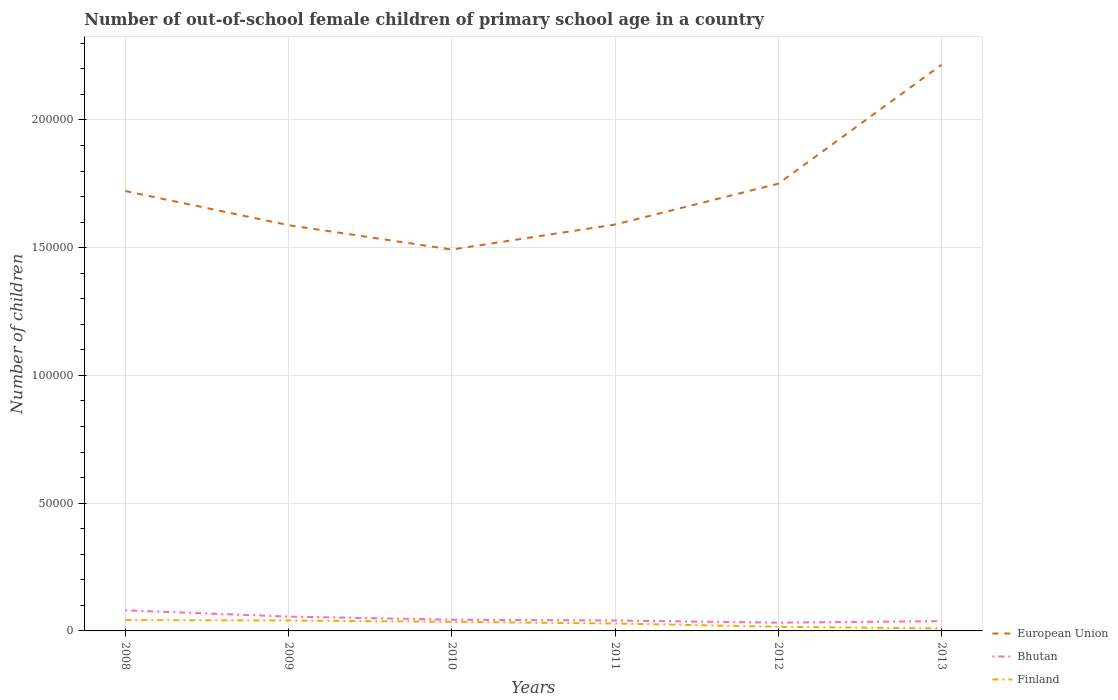How many different coloured lines are there?
Ensure brevity in your answer.  3. Is the number of lines equal to the number of legend labels?
Keep it short and to the point. Yes. Across all years, what is the maximum number of out-of-school female children in Bhutan?
Make the answer very short. 3236. What is the total number of out-of-school female children in Finland in the graph?
Give a very brief answer. 177. What is the difference between the highest and the second highest number of out-of-school female children in European Union?
Offer a very short reply. 7.23e+04. What is the difference between the highest and the lowest number of out-of-school female children in Finland?
Provide a succinct answer. 3. How many lines are there?
Give a very brief answer. 3. Are the values on the major ticks of Y-axis written in scientific E-notation?
Offer a terse response. No. Does the graph contain any zero values?
Keep it short and to the point. No. Where does the legend appear in the graph?
Your answer should be very brief. Bottom right. How are the legend labels stacked?
Keep it short and to the point. Vertical. What is the title of the graph?
Your answer should be compact. Number of out-of-school female children of primary school age in a country. Does "Turkey" appear as one of the legend labels in the graph?
Your answer should be very brief. No. What is the label or title of the Y-axis?
Ensure brevity in your answer.  Number of children. What is the Number of children in European Union in 2008?
Provide a short and direct response. 1.72e+05. What is the Number of children in Bhutan in 2008?
Your answer should be very brief. 8066. What is the Number of children of Finland in 2008?
Your response must be concise. 4262. What is the Number of children in European Union in 2009?
Provide a short and direct response. 1.59e+05. What is the Number of children of Bhutan in 2009?
Your response must be concise. 5613. What is the Number of children in Finland in 2009?
Offer a terse response. 4085. What is the Number of children in European Union in 2010?
Provide a succinct answer. 1.49e+05. What is the Number of children of Bhutan in 2010?
Ensure brevity in your answer.  4390. What is the Number of children in Finland in 2010?
Give a very brief answer. 3564. What is the Number of children in European Union in 2011?
Provide a short and direct response. 1.59e+05. What is the Number of children in Bhutan in 2011?
Give a very brief answer. 4072. What is the Number of children in Finland in 2011?
Make the answer very short. 2896. What is the Number of children in European Union in 2012?
Your answer should be compact. 1.75e+05. What is the Number of children in Bhutan in 2012?
Provide a short and direct response. 3236. What is the Number of children of Finland in 2012?
Give a very brief answer. 1629. What is the Number of children in European Union in 2013?
Provide a short and direct response. 2.22e+05. What is the Number of children of Bhutan in 2013?
Provide a succinct answer. 3839. What is the Number of children of Finland in 2013?
Your answer should be very brief. 958. Across all years, what is the maximum Number of children in European Union?
Your answer should be compact. 2.22e+05. Across all years, what is the maximum Number of children of Bhutan?
Ensure brevity in your answer.  8066. Across all years, what is the maximum Number of children of Finland?
Your response must be concise. 4262. Across all years, what is the minimum Number of children in European Union?
Make the answer very short. 1.49e+05. Across all years, what is the minimum Number of children in Bhutan?
Make the answer very short. 3236. Across all years, what is the minimum Number of children in Finland?
Offer a terse response. 958. What is the total Number of children in European Union in the graph?
Your answer should be very brief. 1.04e+06. What is the total Number of children of Bhutan in the graph?
Give a very brief answer. 2.92e+04. What is the total Number of children in Finland in the graph?
Provide a short and direct response. 1.74e+04. What is the difference between the Number of children in European Union in 2008 and that in 2009?
Your answer should be compact. 1.34e+04. What is the difference between the Number of children in Bhutan in 2008 and that in 2009?
Keep it short and to the point. 2453. What is the difference between the Number of children of Finland in 2008 and that in 2009?
Provide a succinct answer. 177. What is the difference between the Number of children in European Union in 2008 and that in 2010?
Your response must be concise. 2.29e+04. What is the difference between the Number of children in Bhutan in 2008 and that in 2010?
Provide a succinct answer. 3676. What is the difference between the Number of children in Finland in 2008 and that in 2010?
Give a very brief answer. 698. What is the difference between the Number of children in European Union in 2008 and that in 2011?
Make the answer very short. 1.31e+04. What is the difference between the Number of children of Bhutan in 2008 and that in 2011?
Your answer should be compact. 3994. What is the difference between the Number of children in Finland in 2008 and that in 2011?
Provide a short and direct response. 1366. What is the difference between the Number of children in European Union in 2008 and that in 2012?
Provide a short and direct response. -2863. What is the difference between the Number of children in Bhutan in 2008 and that in 2012?
Provide a succinct answer. 4830. What is the difference between the Number of children of Finland in 2008 and that in 2012?
Your response must be concise. 2633. What is the difference between the Number of children in European Union in 2008 and that in 2013?
Your response must be concise. -4.94e+04. What is the difference between the Number of children in Bhutan in 2008 and that in 2013?
Make the answer very short. 4227. What is the difference between the Number of children of Finland in 2008 and that in 2013?
Give a very brief answer. 3304. What is the difference between the Number of children of European Union in 2009 and that in 2010?
Your answer should be very brief. 9539. What is the difference between the Number of children in Bhutan in 2009 and that in 2010?
Make the answer very short. 1223. What is the difference between the Number of children in Finland in 2009 and that in 2010?
Provide a succinct answer. 521. What is the difference between the Number of children of European Union in 2009 and that in 2011?
Your response must be concise. -235. What is the difference between the Number of children of Bhutan in 2009 and that in 2011?
Offer a very short reply. 1541. What is the difference between the Number of children of Finland in 2009 and that in 2011?
Provide a short and direct response. 1189. What is the difference between the Number of children in European Union in 2009 and that in 2012?
Offer a very short reply. -1.62e+04. What is the difference between the Number of children in Bhutan in 2009 and that in 2012?
Give a very brief answer. 2377. What is the difference between the Number of children of Finland in 2009 and that in 2012?
Give a very brief answer. 2456. What is the difference between the Number of children of European Union in 2009 and that in 2013?
Your answer should be compact. -6.28e+04. What is the difference between the Number of children of Bhutan in 2009 and that in 2013?
Your response must be concise. 1774. What is the difference between the Number of children of Finland in 2009 and that in 2013?
Give a very brief answer. 3127. What is the difference between the Number of children in European Union in 2010 and that in 2011?
Ensure brevity in your answer.  -9774. What is the difference between the Number of children in Bhutan in 2010 and that in 2011?
Ensure brevity in your answer.  318. What is the difference between the Number of children of Finland in 2010 and that in 2011?
Keep it short and to the point. 668. What is the difference between the Number of children of European Union in 2010 and that in 2012?
Your answer should be compact. -2.58e+04. What is the difference between the Number of children in Bhutan in 2010 and that in 2012?
Keep it short and to the point. 1154. What is the difference between the Number of children of Finland in 2010 and that in 2012?
Your response must be concise. 1935. What is the difference between the Number of children in European Union in 2010 and that in 2013?
Provide a succinct answer. -7.23e+04. What is the difference between the Number of children of Bhutan in 2010 and that in 2013?
Offer a terse response. 551. What is the difference between the Number of children in Finland in 2010 and that in 2013?
Your answer should be compact. 2606. What is the difference between the Number of children in European Union in 2011 and that in 2012?
Ensure brevity in your answer.  -1.60e+04. What is the difference between the Number of children in Bhutan in 2011 and that in 2012?
Offer a very short reply. 836. What is the difference between the Number of children in Finland in 2011 and that in 2012?
Your answer should be very brief. 1267. What is the difference between the Number of children of European Union in 2011 and that in 2013?
Make the answer very short. -6.25e+04. What is the difference between the Number of children in Bhutan in 2011 and that in 2013?
Provide a short and direct response. 233. What is the difference between the Number of children of Finland in 2011 and that in 2013?
Your answer should be compact. 1938. What is the difference between the Number of children in European Union in 2012 and that in 2013?
Your answer should be compact. -4.65e+04. What is the difference between the Number of children of Bhutan in 2012 and that in 2013?
Offer a very short reply. -603. What is the difference between the Number of children in Finland in 2012 and that in 2013?
Give a very brief answer. 671. What is the difference between the Number of children of European Union in 2008 and the Number of children of Bhutan in 2009?
Provide a succinct answer. 1.67e+05. What is the difference between the Number of children in European Union in 2008 and the Number of children in Finland in 2009?
Your response must be concise. 1.68e+05. What is the difference between the Number of children in Bhutan in 2008 and the Number of children in Finland in 2009?
Give a very brief answer. 3981. What is the difference between the Number of children of European Union in 2008 and the Number of children of Bhutan in 2010?
Ensure brevity in your answer.  1.68e+05. What is the difference between the Number of children of European Union in 2008 and the Number of children of Finland in 2010?
Offer a terse response. 1.69e+05. What is the difference between the Number of children in Bhutan in 2008 and the Number of children in Finland in 2010?
Ensure brevity in your answer.  4502. What is the difference between the Number of children of European Union in 2008 and the Number of children of Bhutan in 2011?
Offer a terse response. 1.68e+05. What is the difference between the Number of children of European Union in 2008 and the Number of children of Finland in 2011?
Your answer should be very brief. 1.69e+05. What is the difference between the Number of children of Bhutan in 2008 and the Number of children of Finland in 2011?
Provide a succinct answer. 5170. What is the difference between the Number of children of European Union in 2008 and the Number of children of Bhutan in 2012?
Your answer should be compact. 1.69e+05. What is the difference between the Number of children of European Union in 2008 and the Number of children of Finland in 2012?
Your response must be concise. 1.71e+05. What is the difference between the Number of children of Bhutan in 2008 and the Number of children of Finland in 2012?
Give a very brief answer. 6437. What is the difference between the Number of children of European Union in 2008 and the Number of children of Bhutan in 2013?
Keep it short and to the point. 1.68e+05. What is the difference between the Number of children in European Union in 2008 and the Number of children in Finland in 2013?
Your response must be concise. 1.71e+05. What is the difference between the Number of children in Bhutan in 2008 and the Number of children in Finland in 2013?
Your answer should be very brief. 7108. What is the difference between the Number of children of European Union in 2009 and the Number of children of Bhutan in 2010?
Your response must be concise. 1.54e+05. What is the difference between the Number of children of European Union in 2009 and the Number of children of Finland in 2010?
Ensure brevity in your answer.  1.55e+05. What is the difference between the Number of children in Bhutan in 2009 and the Number of children in Finland in 2010?
Keep it short and to the point. 2049. What is the difference between the Number of children of European Union in 2009 and the Number of children of Bhutan in 2011?
Give a very brief answer. 1.55e+05. What is the difference between the Number of children of European Union in 2009 and the Number of children of Finland in 2011?
Provide a succinct answer. 1.56e+05. What is the difference between the Number of children in Bhutan in 2009 and the Number of children in Finland in 2011?
Your answer should be compact. 2717. What is the difference between the Number of children of European Union in 2009 and the Number of children of Bhutan in 2012?
Your answer should be very brief. 1.56e+05. What is the difference between the Number of children in European Union in 2009 and the Number of children in Finland in 2012?
Your answer should be very brief. 1.57e+05. What is the difference between the Number of children in Bhutan in 2009 and the Number of children in Finland in 2012?
Make the answer very short. 3984. What is the difference between the Number of children of European Union in 2009 and the Number of children of Bhutan in 2013?
Provide a succinct answer. 1.55e+05. What is the difference between the Number of children of European Union in 2009 and the Number of children of Finland in 2013?
Your answer should be compact. 1.58e+05. What is the difference between the Number of children of Bhutan in 2009 and the Number of children of Finland in 2013?
Ensure brevity in your answer.  4655. What is the difference between the Number of children in European Union in 2010 and the Number of children in Bhutan in 2011?
Give a very brief answer. 1.45e+05. What is the difference between the Number of children in European Union in 2010 and the Number of children in Finland in 2011?
Provide a succinct answer. 1.46e+05. What is the difference between the Number of children of Bhutan in 2010 and the Number of children of Finland in 2011?
Provide a succinct answer. 1494. What is the difference between the Number of children in European Union in 2010 and the Number of children in Bhutan in 2012?
Your response must be concise. 1.46e+05. What is the difference between the Number of children of European Union in 2010 and the Number of children of Finland in 2012?
Keep it short and to the point. 1.48e+05. What is the difference between the Number of children in Bhutan in 2010 and the Number of children in Finland in 2012?
Provide a succinct answer. 2761. What is the difference between the Number of children of European Union in 2010 and the Number of children of Bhutan in 2013?
Offer a very short reply. 1.45e+05. What is the difference between the Number of children in European Union in 2010 and the Number of children in Finland in 2013?
Give a very brief answer. 1.48e+05. What is the difference between the Number of children of Bhutan in 2010 and the Number of children of Finland in 2013?
Ensure brevity in your answer.  3432. What is the difference between the Number of children in European Union in 2011 and the Number of children in Bhutan in 2012?
Your answer should be compact. 1.56e+05. What is the difference between the Number of children of European Union in 2011 and the Number of children of Finland in 2012?
Ensure brevity in your answer.  1.57e+05. What is the difference between the Number of children of Bhutan in 2011 and the Number of children of Finland in 2012?
Your response must be concise. 2443. What is the difference between the Number of children of European Union in 2011 and the Number of children of Bhutan in 2013?
Ensure brevity in your answer.  1.55e+05. What is the difference between the Number of children of European Union in 2011 and the Number of children of Finland in 2013?
Your answer should be very brief. 1.58e+05. What is the difference between the Number of children in Bhutan in 2011 and the Number of children in Finland in 2013?
Your answer should be very brief. 3114. What is the difference between the Number of children of European Union in 2012 and the Number of children of Bhutan in 2013?
Make the answer very short. 1.71e+05. What is the difference between the Number of children of European Union in 2012 and the Number of children of Finland in 2013?
Your answer should be very brief. 1.74e+05. What is the difference between the Number of children in Bhutan in 2012 and the Number of children in Finland in 2013?
Give a very brief answer. 2278. What is the average Number of children of European Union per year?
Ensure brevity in your answer.  1.73e+05. What is the average Number of children in Bhutan per year?
Provide a succinct answer. 4869.33. What is the average Number of children of Finland per year?
Your answer should be very brief. 2899. In the year 2008, what is the difference between the Number of children of European Union and Number of children of Bhutan?
Provide a succinct answer. 1.64e+05. In the year 2008, what is the difference between the Number of children of European Union and Number of children of Finland?
Your response must be concise. 1.68e+05. In the year 2008, what is the difference between the Number of children in Bhutan and Number of children in Finland?
Your answer should be compact. 3804. In the year 2009, what is the difference between the Number of children of European Union and Number of children of Bhutan?
Your answer should be very brief. 1.53e+05. In the year 2009, what is the difference between the Number of children in European Union and Number of children in Finland?
Keep it short and to the point. 1.55e+05. In the year 2009, what is the difference between the Number of children of Bhutan and Number of children of Finland?
Offer a terse response. 1528. In the year 2010, what is the difference between the Number of children in European Union and Number of children in Bhutan?
Offer a terse response. 1.45e+05. In the year 2010, what is the difference between the Number of children in European Union and Number of children in Finland?
Give a very brief answer. 1.46e+05. In the year 2010, what is the difference between the Number of children of Bhutan and Number of children of Finland?
Ensure brevity in your answer.  826. In the year 2011, what is the difference between the Number of children in European Union and Number of children in Bhutan?
Offer a terse response. 1.55e+05. In the year 2011, what is the difference between the Number of children of European Union and Number of children of Finland?
Offer a terse response. 1.56e+05. In the year 2011, what is the difference between the Number of children in Bhutan and Number of children in Finland?
Make the answer very short. 1176. In the year 2012, what is the difference between the Number of children of European Union and Number of children of Bhutan?
Offer a very short reply. 1.72e+05. In the year 2012, what is the difference between the Number of children of European Union and Number of children of Finland?
Your answer should be very brief. 1.73e+05. In the year 2012, what is the difference between the Number of children of Bhutan and Number of children of Finland?
Your answer should be very brief. 1607. In the year 2013, what is the difference between the Number of children in European Union and Number of children in Bhutan?
Give a very brief answer. 2.18e+05. In the year 2013, what is the difference between the Number of children in European Union and Number of children in Finland?
Ensure brevity in your answer.  2.21e+05. In the year 2013, what is the difference between the Number of children of Bhutan and Number of children of Finland?
Provide a short and direct response. 2881. What is the ratio of the Number of children of European Union in 2008 to that in 2009?
Give a very brief answer. 1.08. What is the ratio of the Number of children in Bhutan in 2008 to that in 2009?
Keep it short and to the point. 1.44. What is the ratio of the Number of children of Finland in 2008 to that in 2009?
Offer a very short reply. 1.04. What is the ratio of the Number of children of European Union in 2008 to that in 2010?
Provide a short and direct response. 1.15. What is the ratio of the Number of children in Bhutan in 2008 to that in 2010?
Give a very brief answer. 1.84. What is the ratio of the Number of children in Finland in 2008 to that in 2010?
Provide a succinct answer. 1.2. What is the ratio of the Number of children in European Union in 2008 to that in 2011?
Your response must be concise. 1.08. What is the ratio of the Number of children in Bhutan in 2008 to that in 2011?
Keep it short and to the point. 1.98. What is the ratio of the Number of children of Finland in 2008 to that in 2011?
Keep it short and to the point. 1.47. What is the ratio of the Number of children of European Union in 2008 to that in 2012?
Ensure brevity in your answer.  0.98. What is the ratio of the Number of children in Bhutan in 2008 to that in 2012?
Provide a succinct answer. 2.49. What is the ratio of the Number of children in Finland in 2008 to that in 2012?
Your answer should be compact. 2.62. What is the ratio of the Number of children of European Union in 2008 to that in 2013?
Your answer should be compact. 0.78. What is the ratio of the Number of children of Bhutan in 2008 to that in 2013?
Your answer should be very brief. 2.1. What is the ratio of the Number of children in Finland in 2008 to that in 2013?
Ensure brevity in your answer.  4.45. What is the ratio of the Number of children in European Union in 2009 to that in 2010?
Provide a short and direct response. 1.06. What is the ratio of the Number of children in Bhutan in 2009 to that in 2010?
Your response must be concise. 1.28. What is the ratio of the Number of children of Finland in 2009 to that in 2010?
Make the answer very short. 1.15. What is the ratio of the Number of children of European Union in 2009 to that in 2011?
Offer a very short reply. 1. What is the ratio of the Number of children of Bhutan in 2009 to that in 2011?
Keep it short and to the point. 1.38. What is the ratio of the Number of children in Finland in 2009 to that in 2011?
Provide a succinct answer. 1.41. What is the ratio of the Number of children in European Union in 2009 to that in 2012?
Ensure brevity in your answer.  0.91. What is the ratio of the Number of children in Bhutan in 2009 to that in 2012?
Your answer should be very brief. 1.73. What is the ratio of the Number of children in Finland in 2009 to that in 2012?
Your answer should be very brief. 2.51. What is the ratio of the Number of children of European Union in 2009 to that in 2013?
Offer a very short reply. 0.72. What is the ratio of the Number of children of Bhutan in 2009 to that in 2013?
Offer a very short reply. 1.46. What is the ratio of the Number of children of Finland in 2009 to that in 2013?
Offer a very short reply. 4.26. What is the ratio of the Number of children of European Union in 2010 to that in 2011?
Offer a very short reply. 0.94. What is the ratio of the Number of children in Bhutan in 2010 to that in 2011?
Your answer should be compact. 1.08. What is the ratio of the Number of children of Finland in 2010 to that in 2011?
Ensure brevity in your answer.  1.23. What is the ratio of the Number of children in European Union in 2010 to that in 2012?
Your response must be concise. 0.85. What is the ratio of the Number of children of Bhutan in 2010 to that in 2012?
Offer a very short reply. 1.36. What is the ratio of the Number of children of Finland in 2010 to that in 2012?
Offer a very short reply. 2.19. What is the ratio of the Number of children in European Union in 2010 to that in 2013?
Give a very brief answer. 0.67. What is the ratio of the Number of children in Bhutan in 2010 to that in 2013?
Your response must be concise. 1.14. What is the ratio of the Number of children in Finland in 2010 to that in 2013?
Provide a short and direct response. 3.72. What is the ratio of the Number of children in European Union in 2011 to that in 2012?
Your response must be concise. 0.91. What is the ratio of the Number of children in Bhutan in 2011 to that in 2012?
Your answer should be compact. 1.26. What is the ratio of the Number of children in Finland in 2011 to that in 2012?
Offer a very short reply. 1.78. What is the ratio of the Number of children of European Union in 2011 to that in 2013?
Ensure brevity in your answer.  0.72. What is the ratio of the Number of children in Bhutan in 2011 to that in 2013?
Offer a very short reply. 1.06. What is the ratio of the Number of children of Finland in 2011 to that in 2013?
Your response must be concise. 3.02. What is the ratio of the Number of children in European Union in 2012 to that in 2013?
Give a very brief answer. 0.79. What is the ratio of the Number of children of Bhutan in 2012 to that in 2013?
Keep it short and to the point. 0.84. What is the ratio of the Number of children of Finland in 2012 to that in 2013?
Offer a very short reply. 1.7. What is the difference between the highest and the second highest Number of children in European Union?
Give a very brief answer. 4.65e+04. What is the difference between the highest and the second highest Number of children in Bhutan?
Provide a short and direct response. 2453. What is the difference between the highest and the second highest Number of children in Finland?
Keep it short and to the point. 177. What is the difference between the highest and the lowest Number of children in European Union?
Offer a very short reply. 7.23e+04. What is the difference between the highest and the lowest Number of children of Bhutan?
Provide a succinct answer. 4830. What is the difference between the highest and the lowest Number of children of Finland?
Make the answer very short. 3304. 